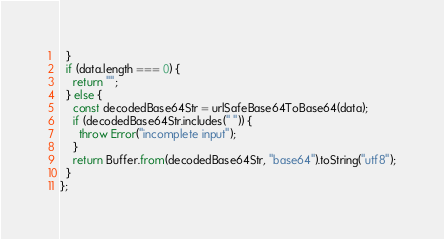Convert code to text. <code><loc_0><loc_0><loc_500><loc_500><_TypeScript_>  }
  if (data.length === 0) {
    return "";
  } else {
    const decodedBase64Str = urlSafeBase64ToBase64(data);
    if (decodedBase64Str.includes(" ")) {
      throw Error("incomplete input");
    }
    return Buffer.from(decodedBase64Str, "base64").toString("utf8");
  }
};
</code> 